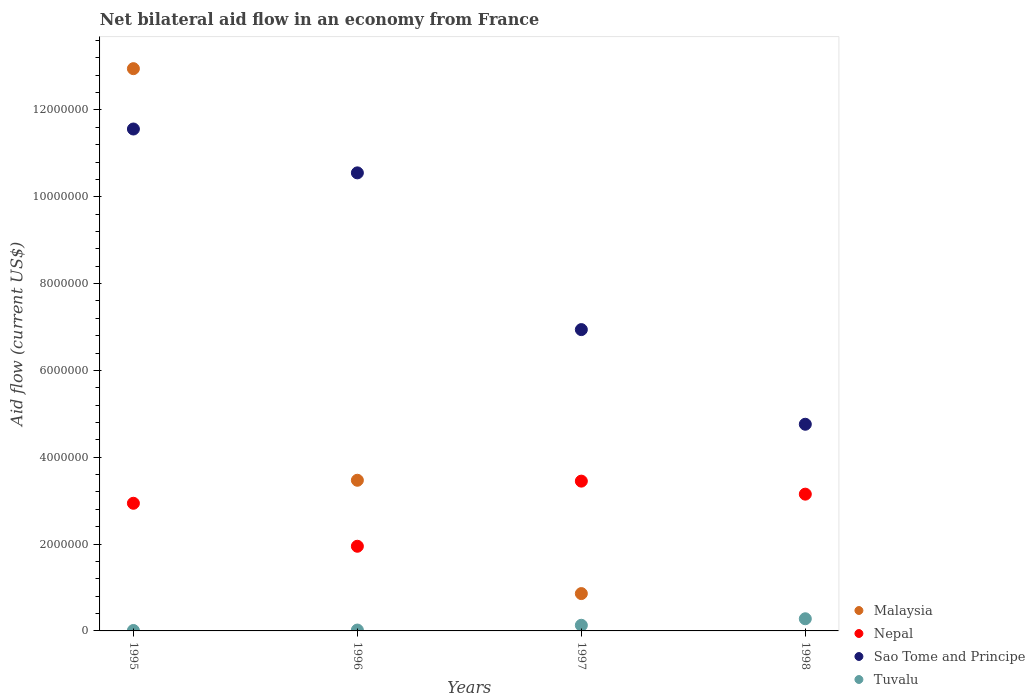Is the number of dotlines equal to the number of legend labels?
Keep it short and to the point. No. What is the net bilateral aid flow in Sao Tome and Principe in 1998?
Ensure brevity in your answer.  4.76e+06. Across all years, what is the maximum net bilateral aid flow in Malaysia?
Give a very brief answer. 1.30e+07. What is the total net bilateral aid flow in Tuvalu in the graph?
Keep it short and to the point. 4.40e+05. What is the difference between the net bilateral aid flow in Nepal in 1996 and that in 1997?
Offer a very short reply. -1.50e+06. What is the difference between the net bilateral aid flow in Malaysia in 1998 and the net bilateral aid flow in Sao Tome and Principe in 1995?
Make the answer very short. -1.16e+07. What is the average net bilateral aid flow in Nepal per year?
Ensure brevity in your answer.  2.87e+06. In the year 1996, what is the difference between the net bilateral aid flow in Nepal and net bilateral aid flow in Tuvalu?
Ensure brevity in your answer.  1.93e+06. In how many years, is the net bilateral aid flow in Malaysia greater than 11600000 US$?
Provide a short and direct response. 1. What is the ratio of the net bilateral aid flow in Tuvalu in 1996 to that in 1998?
Offer a terse response. 0.07. What is the difference between the highest and the lowest net bilateral aid flow in Sao Tome and Principe?
Ensure brevity in your answer.  6.80e+06. Is it the case that in every year, the sum of the net bilateral aid flow in Malaysia and net bilateral aid flow in Tuvalu  is greater than the sum of net bilateral aid flow in Sao Tome and Principe and net bilateral aid flow in Nepal?
Give a very brief answer. No. Is it the case that in every year, the sum of the net bilateral aid flow in Nepal and net bilateral aid flow in Malaysia  is greater than the net bilateral aid flow in Sao Tome and Principe?
Offer a very short reply. No. Is the net bilateral aid flow in Sao Tome and Principe strictly less than the net bilateral aid flow in Tuvalu over the years?
Keep it short and to the point. No. What is the difference between two consecutive major ticks on the Y-axis?
Offer a terse response. 2.00e+06. Where does the legend appear in the graph?
Your answer should be very brief. Bottom right. How many legend labels are there?
Your answer should be very brief. 4. How are the legend labels stacked?
Provide a succinct answer. Vertical. What is the title of the graph?
Your response must be concise. Net bilateral aid flow in an economy from France. Does "Mongolia" appear as one of the legend labels in the graph?
Give a very brief answer. No. What is the label or title of the X-axis?
Your answer should be very brief. Years. What is the Aid flow (current US$) in Malaysia in 1995?
Ensure brevity in your answer.  1.30e+07. What is the Aid flow (current US$) in Nepal in 1995?
Make the answer very short. 2.94e+06. What is the Aid flow (current US$) in Sao Tome and Principe in 1995?
Provide a short and direct response. 1.16e+07. What is the Aid flow (current US$) of Tuvalu in 1995?
Your answer should be very brief. 10000. What is the Aid flow (current US$) of Malaysia in 1996?
Provide a short and direct response. 3.47e+06. What is the Aid flow (current US$) of Nepal in 1996?
Provide a succinct answer. 1.95e+06. What is the Aid flow (current US$) of Sao Tome and Principe in 1996?
Offer a terse response. 1.06e+07. What is the Aid flow (current US$) in Tuvalu in 1996?
Ensure brevity in your answer.  2.00e+04. What is the Aid flow (current US$) of Malaysia in 1997?
Make the answer very short. 8.60e+05. What is the Aid flow (current US$) of Nepal in 1997?
Ensure brevity in your answer.  3.45e+06. What is the Aid flow (current US$) of Sao Tome and Principe in 1997?
Keep it short and to the point. 6.94e+06. What is the Aid flow (current US$) in Malaysia in 1998?
Ensure brevity in your answer.  0. What is the Aid flow (current US$) of Nepal in 1998?
Your answer should be very brief. 3.15e+06. What is the Aid flow (current US$) of Sao Tome and Principe in 1998?
Offer a very short reply. 4.76e+06. Across all years, what is the maximum Aid flow (current US$) of Malaysia?
Keep it short and to the point. 1.30e+07. Across all years, what is the maximum Aid flow (current US$) of Nepal?
Your response must be concise. 3.45e+06. Across all years, what is the maximum Aid flow (current US$) in Sao Tome and Principe?
Your response must be concise. 1.16e+07. Across all years, what is the maximum Aid flow (current US$) in Tuvalu?
Give a very brief answer. 2.80e+05. Across all years, what is the minimum Aid flow (current US$) in Malaysia?
Offer a terse response. 0. Across all years, what is the minimum Aid flow (current US$) of Nepal?
Your response must be concise. 1.95e+06. Across all years, what is the minimum Aid flow (current US$) of Sao Tome and Principe?
Make the answer very short. 4.76e+06. Across all years, what is the minimum Aid flow (current US$) of Tuvalu?
Make the answer very short. 10000. What is the total Aid flow (current US$) of Malaysia in the graph?
Your answer should be very brief. 1.73e+07. What is the total Aid flow (current US$) in Nepal in the graph?
Make the answer very short. 1.15e+07. What is the total Aid flow (current US$) in Sao Tome and Principe in the graph?
Your answer should be very brief. 3.38e+07. What is the difference between the Aid flow (current US$) in Malaysia in 1995 and that in 1996?
Make the answer very short. 9.48e+06. What is the difference between the Aid flow (current US$) in Nepal in 1995 and that in 1996?
Provide a succinct answer. 9.90e+05. What is the difference between the Aid flow (current US$) in Sao Tome and Principe in 1995 and that in 1996?
Make the answer very short. 1.01e+06. What is the difference between the Aid flow (current US$) of Malaysia in 1995 and that in 1997?
Give a very brief answer. 1.21e+07. What is the difference between the Aid flow (current US$) in Nepal in 1995 and that in 1997?
Your answer should be very brief. -5.10e+05. What is the difference between the Aid flow (current US$) in Sao Tome and Principe in 1995 and that in 1997?
Keep it short and to the point. 4.62e+06. What is the difference between the Aid flow (current US$) in Nepal in 1995 and that in 1998?
Keep it short and to the point. -2.10e+05. What is the difference between the Aid flow (current US$) in Sao Tome and Principe in 1995 and that in 1998?
Make the answer very short. 6.80e+06. What is the difference between the Aid flow (current US$) of Malaysia in 1996 and that in 1997?
Offer a very short reply. 2.61e+06. What is the difference between the Aid flow (current US$) of Nepal in 1996 and that in 1997?
Keep it short and to the point. -1.50e+06. What is the difference between the Aid flow (current US$) of Sao Tome and Principe in 1996 and that in 1997?
Your answer should be very brief. 3.61e+06. What is the difference between the Aid flow (current US$) of Tuvalu in 1996 and that in 1997?
Your answer should be very brief. -1.10e+05. What is the difference between the Aid flow (current US$) in Nepal in 1996 and that in 1998?
Provide a short and direct response. -1.20e+06. What is the difference between the Aid flow (current US$) of Sao Tome and Principe in 1996 and that in 1998?
Your answer should be very brief. 5.79e+06. What is the difference between the Aid flow (current US$) in Sao Tome and Principe in 1997 and that in 1998?
Your answer should be very brief. 2.18e+06. What is the difference between the Aid flow (current US$) in Malaysia in 1995 and the Aid flow (current US$) in Nepal in 1996?
Offer a terse response. 1.10e+07. What is the difference between the Aid flow (current US$) in Malaysia in 1995 and the Aid flow (current US$) in Sao Tome and Principe in 1996?
Keep it short and to the point. 2.40e+06. What is the difference between the Aid flow (current US$) of Malaysia in 1995 and the Aid flow (current US$) of Tuvalu in 1996?
Provide a short and direct response. 1.29e+07. What is the difference between the Aid flow (current US$) in Nepal in 1995 and the Aid flow (current US$) in Sao Tome and Principe in 1996?
Make the answer very short. -7.61e+06. What is the difference between the Aid flow (current US$) in Nepal in 1995 and the Aid flow (current US$) in Tuvalu in 1996?
Your response must be concise. 2.92e+06. What is the difference between the Aid flow (current US$) in Sao Tome and Principe in 1995 and the Aid flow (current US$) in Tuvalu in 1996?
Give a very brief answer. 1.15e+07. What is the difference between the Aid flow (current US$) of Malaysia in 1995 and the Aid flow (current US$) of Nepal in 1997?
Offer a terse response. 9.50e+06. What is the difference between the Aid flow (current US$) in Malaysia in 1995 and the Aid flow (current US$) in Sao Tome and Principe in 1997?
Your response must be concise. 6.01e+06. What is the difference between the Aid flow (current US$) of Malaysia in 1995 and the Aid flow (current US$) of Tuvalu in 1997?
Offer a terse response. 1.28e+07. What is the difference between the Aid flow (current US$) in Nepal in 1995 and the Aid flow (current US$) in Sao Tome and Principe in 1997?
Offer a very short reply. -4.00e+06. What is the difference between the Aid flow (current US$) in Nepal in 1995 and the Aid flow (current US$) in Tuvalu in 1997?
Give a very brief answer. 2.81e+06. What is the difference between the Aid flow (current US$) in Sao Tome and Principe in 1995 and the Aid flow (current US$) in Tuvalu in 1997?
Provide a succinct answer. 1.14e+07. What is the difference between the Aid flow (current US$) in Malaysia in 1995 and the Aid flow (current US$) in Nepal in 1998?
Provide a succinct answer. 9.80e+06. What is the difference between the Aid flow (current US$) in Malaysia in 1995 and the Aid flow (current US$) in Sao Tome and Principe in 1998?
Your answer should be compact. 8.19e+06. What is the difference between the Aid flow (current US$) of Malaysia in 1995 and the Aid flow (current US$) of Tuvalu in 1998?
Your answer should be very brief. 1.27e+07. What is the difference between the Aid flow (current US$) of Nepal in 1995 and the Aid flow (current US$) of Sao Tome and Principe in 1998?
Give a very brief answer. -1.82e+06. What is the difference between the Aid flow (current US$) in Nepal in 1995 and the Aid flow (current US$) in Tuvalu in 1998?
Your answer should be very brief. 2.66e+06. What is the difference between the Aid flow (current US$) of Sao Tome and Principe in 1995 and the Aid flow (current US$) of Tuvalu in 1998?
Your answer should be compact. 1.13e+07. What is the difference between the Aid flow (current US$) in Malaysia in 1996 and the Aid flow (current US$) in Nepal in 1997?
Offer a terse response. 2.00e+04. What is the difference between the Aid flow (current US$) in Malaysia in 1996 and the Aid flow (current US$) in Sao Tome and Principe in 1997?
Provide a succinct answer. -3.47e+06. What is the difference between the Aid flow (current US$) of Malaysia in 1996 and the Aid flow (current US$) of Tuvalu in 1997?
Your answer should be very brief. 3.34e+06. What is the difference between the Aid flow (current US$) of Nepal in 1996 and the Aid flow (current US$) of Sao Tome and Principe in 1997?
Offer a terse response. -4.99e+06. What is the difference between the Aid flow (current US$) of Nepal in 1996 and the Aid flow (current US$) of Tuvalu in 1997?
Offer a terse response. 1.82e+06. What is the difference between the Aid flow (current US$) in Sao Tome and Principe in 1996 and the Aid flow (current US$) in Tuvalu in 1997?
Offer a terse response. 1.04e+07. What is the difference between the Aid flow (current US$) of Malaysia in 1996 and the Aid flow (current US$) of Sao Tome and Principe in 1998?
Your response must be concise. -1.29e+06. What is the difference between the Aid flow (current US$) in Malaysia in 1996 and the Aid flow (current US$) in Tuvalu in 1998?
Your response must be concise. 3.19e+06. What is the difference between the Aid flow (current US$) in Nepal in 1996 and the Aid flow (current US$) in Sao Tome and Principe in 1998?
Your answer should be very brief. -2.81e+06. What is the difference between the Aid flow (current US$) in Nepal in 1996 and the Aid flow (current US$) in Tuvalu in 1998?
Offer a terse response. 1.67e+06. What is the difference between the Aid flow (current US$) of Sao Tome and Principe in 1996 and the Aid flow (current US$) of Tuvalu in 1998?
Make the answer very short. 1.03e+07. What is the difference between the Aid flow (current US$) of Malaysia in 1997 and the Aid flow (current US$) of Nepal in 1998?
Make the answer very short. -2.29e+06. What is the difference between the Aid flow (current US$) of Malaysia in 1997 and the Aid flow (current US$) of Sao Tome and Principe in 1998?
Make the answer very short. -3.90e+06. What is the difference between the Aid flow (current US$) in Malaysia in 1997 and the Aid flow (current US$) in Tuvalu in 1998?
Your answer should be compact. 5.80e+05. What is the difference between the Aid flow (current US$) in Nepal in 1997 and the Aid flow (current US$) in Sao Tome and Principe in 1998?
Offer a terse response. -1.31e+06. What is the difference between the Aid flow (current US$) in Nepal in 1997 and the Aid flow (current US$) in Tuvalu in 1998?
Your response must be concise. 3.17e+06. What is the difference between the Aid flow (current US$) in Sao Tome and Principe in 1997 and the Aid flow (current US$) in Tuvalu in 1998?
Your response must be concise. 6.66e+06. What is the average Aid flow (current US$) of Malaysia per year?
Your answer should be compact. 4.32e+06. What is the average Aid flow (current US$) in Nepal per year?
Your answer should be compact. 2.87e+06. What is the average Aid flow (current US$) of Sao Tome and Principe per year?
Your answer should be compact. 8.45e+06. In the year 1995, what is the difference between the Aid flow (current US$) in Malaysia and Aid flow (current US$) in Nepal?
Keep it short and to the point. 1.00e+07. In the year 1995, what is the difference between the Aid flow (current US$) in Malaysia and Aid flow (current US$) in Sao Tome and Principe?
Your response must be concise. 1.39e+06. In the year 1995, what is the difference between the Aid flow (current US$) of Malaysia and Aid flow (current US$) of Tuvalu?
Offer a terse response. 1.29e+07. In the year 1995, what is the difference between the Aid flow (current US$) in Nepal and Aid flow (current US$) in Sao Tome and Principe?
Give a very brief answer. -8.62e+06. In the year 1995, what is the difference between the Aid flow (current US$) of Nepal and Aid flow (current US$) of Tuvalu?
Your answer should be very brief. 2.93e+06. In the year 1995, what is the difference between the Aid flow (current US$) in Sao Tome and Principe and Aid flow (current US$) in Tuvalu?
Make the answer very short. 1.16e+07. In the year 1996, what is the difference between the Aid flow (current US$) in Malaysia and Aid flow (current US$) in Nepal?
Give a very brief answer. 1.52e+06. In the year 1996, what is the difference between the Aid flow (current US$) of Malaysia and Aid flow (current US$) of Sao Tome and Principe?
Keep it short and to the point. -7.08e+06. In the year 1996, what is the difference between the Aid flow (current US$) of Malaysia and Aid flow (current US$) of Tuvalu?
Your answer should be very brief. 3.45e+06. In the year 1996, what is the difference between the Aid flow (current US$) in Nepal and Aid flow (current US$) in Sao Tome and Principe?
Give a very brief answer. -8.60e+06. In the year 1996, what is the difference between the Aid flow (current US$) in Nepal and Aid flow (current US$) in Tuvalu?
Your answer should be very brief. 1.93e+06. In the year 1996, what is the difference between the Aid flow (current US$) of Sao Tome and Principe and Aid flow (current US$) of Tuvalu?
Offer a very short reply. 1.05e+07. In the year 1997, what is the difference between the Aid flow (current US$) of Malaysia and Aid flow (current US$) of Nepal?
Your answer should be very brief. -2.59e+06. In the year 1997, what is the difference between the Aid flow (current US$) in Malaysia and Aid flow (current US$) in Sao Tome and Principe?
Your answer should be compact. -6.08e+06. In the year 1997, what is the difference between the Aid flow (current US$) in Malaysia and Aid flow (current US$) in Tuvalu?
Ensure brevity in your answer.  7.30e+05. In the year 1997, what is the difference between the Aid flow (current US$) in Nepal and Aid flow (current US$) in Sao Tome and Principe?
Your answer should be very brief. -3.49e+06. In the year 1997, what is the difference between the Aid flow (current US$) in Nepal and Aid flow (current US$) in Tuvalu?
Ensure brevity in your answer.  3.32e+06. In the year 1997, what is the difference between the Aid flow (current US$) in Sao Tome and Principe and Aid flow (current US$) in Tuvalu?
Your answer should be compact. 6.81e+06. In the year 1998, what is the difference between the Aid flow (current US$) of Nepal and Aid flow (current US$) of Sao Tome and Principe?
Your response must be concise. -1.61e+06. In the year 1998, what is the difference between the Aid flow (current US$) in Nepal and Aid flow (current US$) in Tuvalu?
Your response must be concise. 2.87e+06. In the year 1998, what is the difference between the Aid flow (current US$) of Sao Tome and Principe and Aid flow (current US$) of Tuvalu?
Your answer should be compact. 4.48e+06. What is the ratio of the Aid flow (current US$) of Malaysia in 1995 to that in 1996?
Provide a succinct answer. 3.73. What is the ratio of the Aid flow (current US$) of Nepal in 1995 to that in 1996?
Give a very brief answer. 1.51. What is the ratio of the Aid flow (current US$) in Sao Tome and Principe in 1995 to that in 1996?
Keep it short and to the point. 1.1. What is the ratio of the Aid flow (current US$) in Tuvalu in 1995 to that in 1996?
Your answer should be very brief. 0.5. What is the ratio of the Aid flow (current US$) of Malaysia in 1995 to that in 1997?
Keep it short and to the point. 15.06. What is the ratio of the Aid flow (current US$) in Nepal in 1995 to that in 1997?
Make the answer very short. 0.85. What is the ratio of the Aid flow (current US$) of Sao Tome and Principe in 1995 to that in 1997?
Your response must be concise. 1.67. What is the ratio of the Aid flow (current US$) in Tuvalu in 1995 to that in 1997?
Your answer should be compact. 0.08. What is the ratio of the Aid flow (current US$) of Nepal in 1995 to that in 1998?
Provide a succinct answer. 0.93. What is the ratio of the Aid flow (current US$) in Sao Tome and Principe in 1995 to that in 1998?
Provide a short and direct response. 2.43. What is the ratio of the Aid flow (current US$) of Tuvalu in 1995 to that in 1998?
Offer a very short reply. 0.04. What is the ratio of the Aid flow (current US$) of Malaysia in 1996 to that in 1997?
Offer a terse response. 4.03. What is the ratio of the Aid flow (current US$) in Nepal in 1996 to that in 1997?
Your answer should be very brief. 0.57. What is the ratio of the Aid flow (current US$) in Sao Tome and Principe in 1996 to that in 1997?
Provide a short and direct response. 1.52. What is the ratio of the Aid flow (current US$) in Tuvalu in 1996 to that in 1997?
Offer a terse response. 0.15. What is the ratio of the Aid flow (current US$) of Nepal in 1996 to that in 1998?
Keep it short and to the point. 0.62. What is the ratio of the Aid flow (current US$) of Sao Tome and Principe in 1996 to that in 1998?
Ensure brevity in your answer.  2.22. What is the ratio of the Aid flow (current US$) in Tuvalu in 1996 to that in 1998?
Your answer should be very brief. 0.07. What is the ratio of the Aid flow (current US$) in Nepal in 1997 to that in 1998?
Ensure brevity in your answer.  1.1. What is the ratio of the Aid flow (current US$) of Sao Tome and Principe in 1997 to that in 1998?
Ensure brevity in your answer.  1.46. What is the ratio of the Aid flow (current US$) in Tuvalu in 1997 to that in 1998?
Your answer should be compact. 0.46. What is the difference between the highest and the second highest Aid flow (current US$) in Malaysia?
Ensure brevity in your answer.  9.48e+06. What is the difference between the highest and the second highest Aid flow (current US$) of Sao Tome and Principe?
Your answer should be compact. 1.01e+06. What is the difference between the highest and the lowest Aid flow (current US$) of Malaysia?
Give a very brief answer. 1.30e+07. What is the difference between the highest and the lowest Aid flow (current US$) in Nepal?
Make the answer very short. 1.50e+06. What is the difference between the highest and the lowest Aid flow (current US$) of Sao Tome and Principe?
Your answer should be compact. 6.80e+06. What is the difference between the highest and the lowest Aid flow (current US$) in Tuvalu?
Keep it short and to the point. 2.70e+05. 